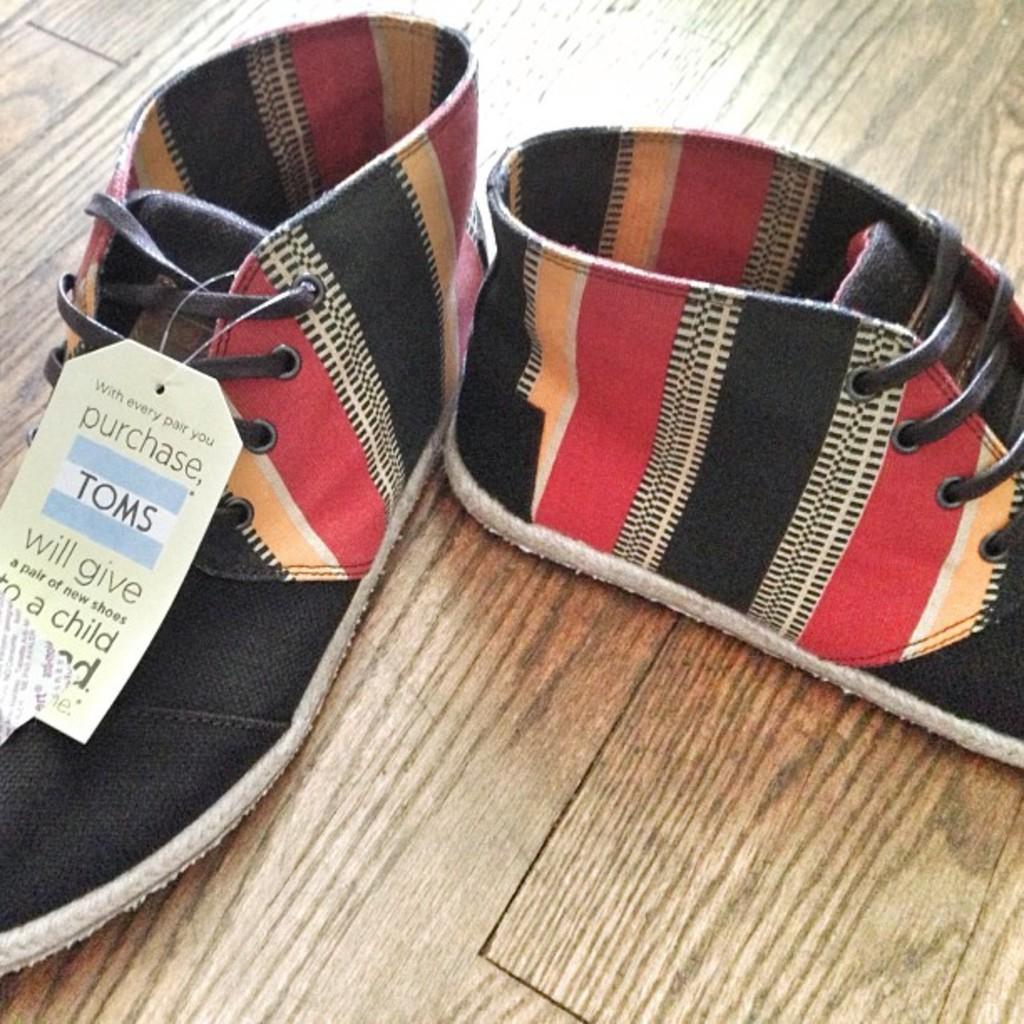Describe this image in one or two sentences. In the center of the image there are shoes on the wooden surface. 